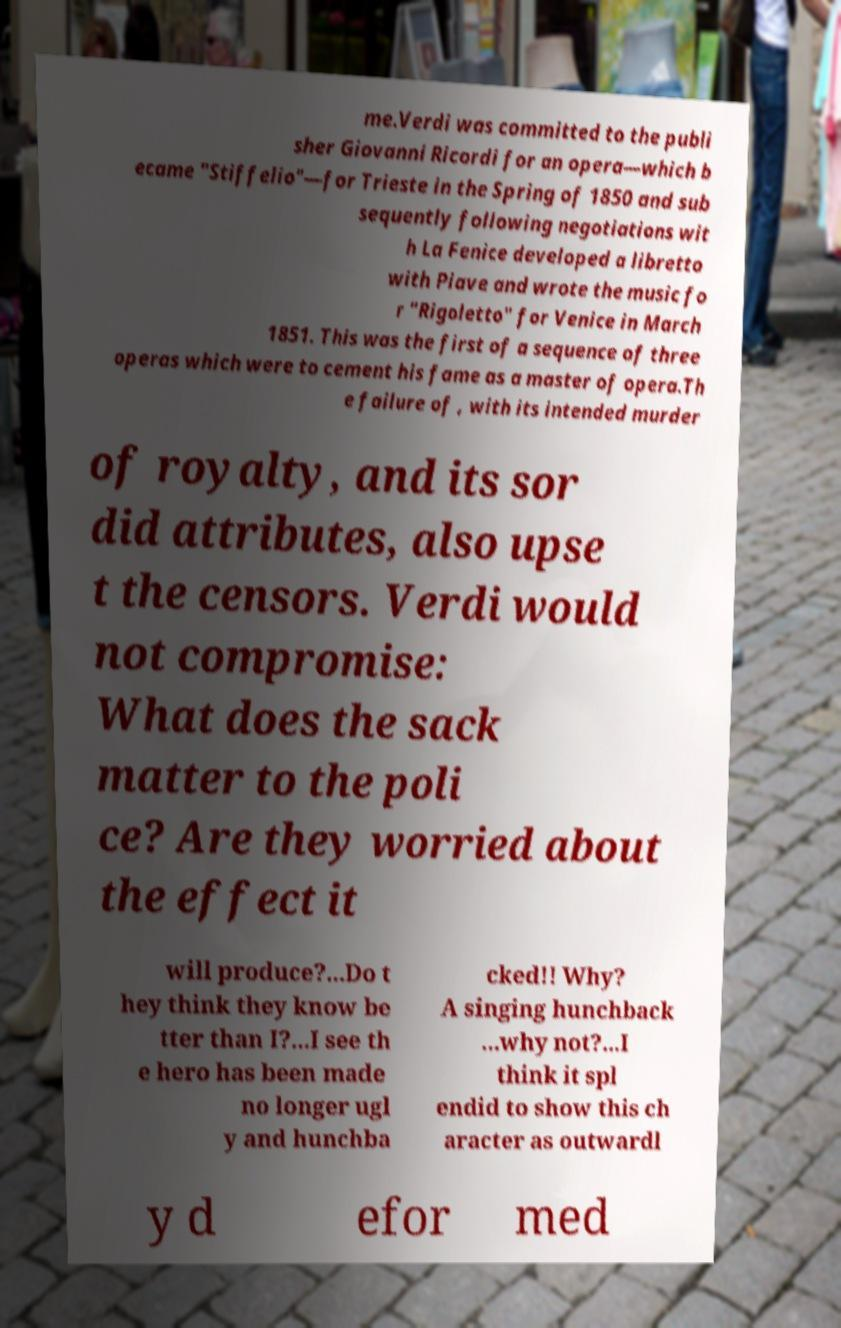There's text embedded in this image that I need extracted. Can you transcribe it verbatim? me.Verdi was committed to the publi sher Giovanni Ricordi for an opera—which b ecame "Stiffelio"—for Trieste in the Spring of 1850 and sub sequently following negotiations wit h La Fenice developed a libretto with Piave and wrote the music fo r "Rigoletto" for Venice in March 1851. This was the first of a sequence of three operas which were to cement his fame as a master of opera.Th e failure of , with its intended murder of royalty, and its sor did attributes, also upse t the censors. Verdi would not compromise: What does the sack matter to the poli ce? Are they worried about the effect it will produce?...Do t hey think they know be tter than I?...I see th e hero has been made no longer ugl y and hunchba cked!! Why? A singing hunchback ...why not?...I think it spl endid to show this ch aracter as outwardl y d efor med 